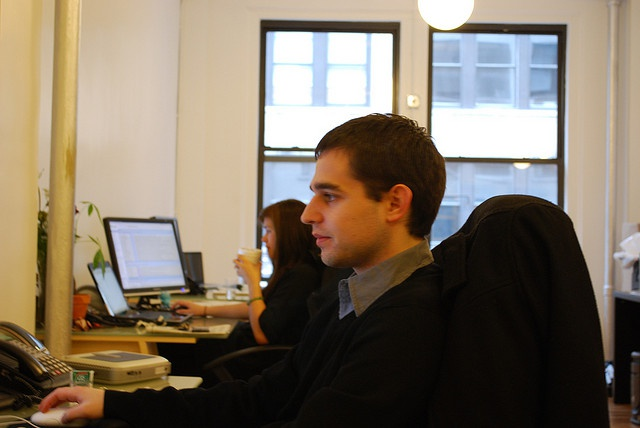Describe the objects in this image and their specific colors. I can see people in tan, black, brown, and maroon tones, chair in tan, black, and gray tones, people in tan, black, brown, maroon, and salmon tones, tv in tan, lavender, and black tones, and laptop in tan, darkgray, black, and gray tones in this image. 